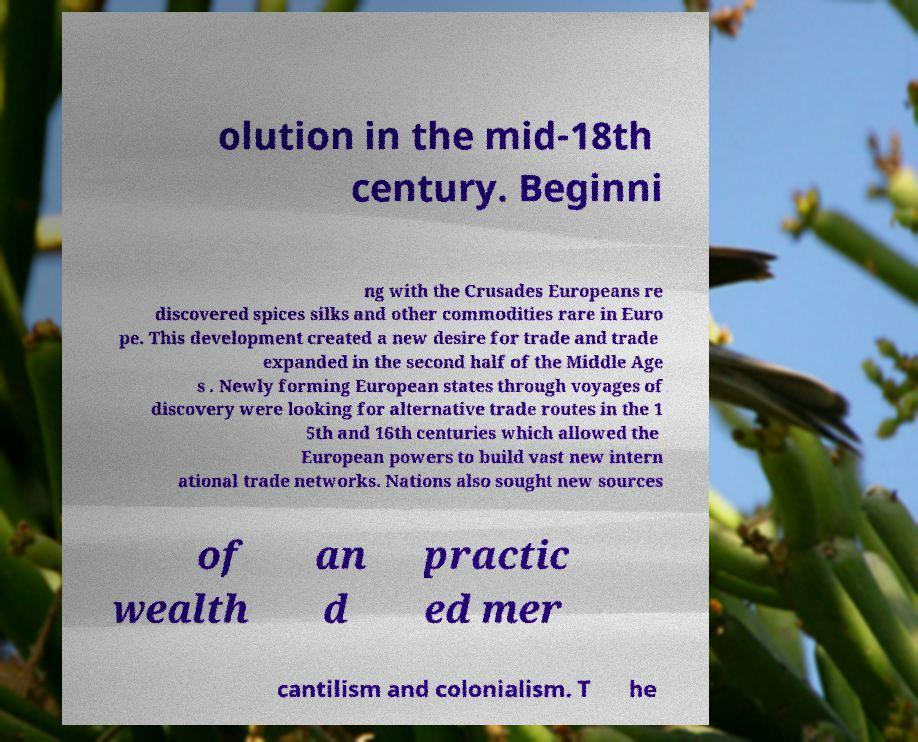For documentation purposes, I need the text within this image transcribed. Could you provide that? olution in the mid-18th century. Beginni ng with the Crusades Europeans re discovered spices silks and other commodities rare in Euro pe. This development created a new desire for trade and trade expanded in the second half of the Middle Age s . Newly forming European states through voyages of discovery were looking for alternative trade routes in the 1 5th and 16th centuries which allowed the European powers to build vast new intern ational trade networks. Nations also sought new sources of wealth an d practic ed mer cantilism and colonialism. T he 